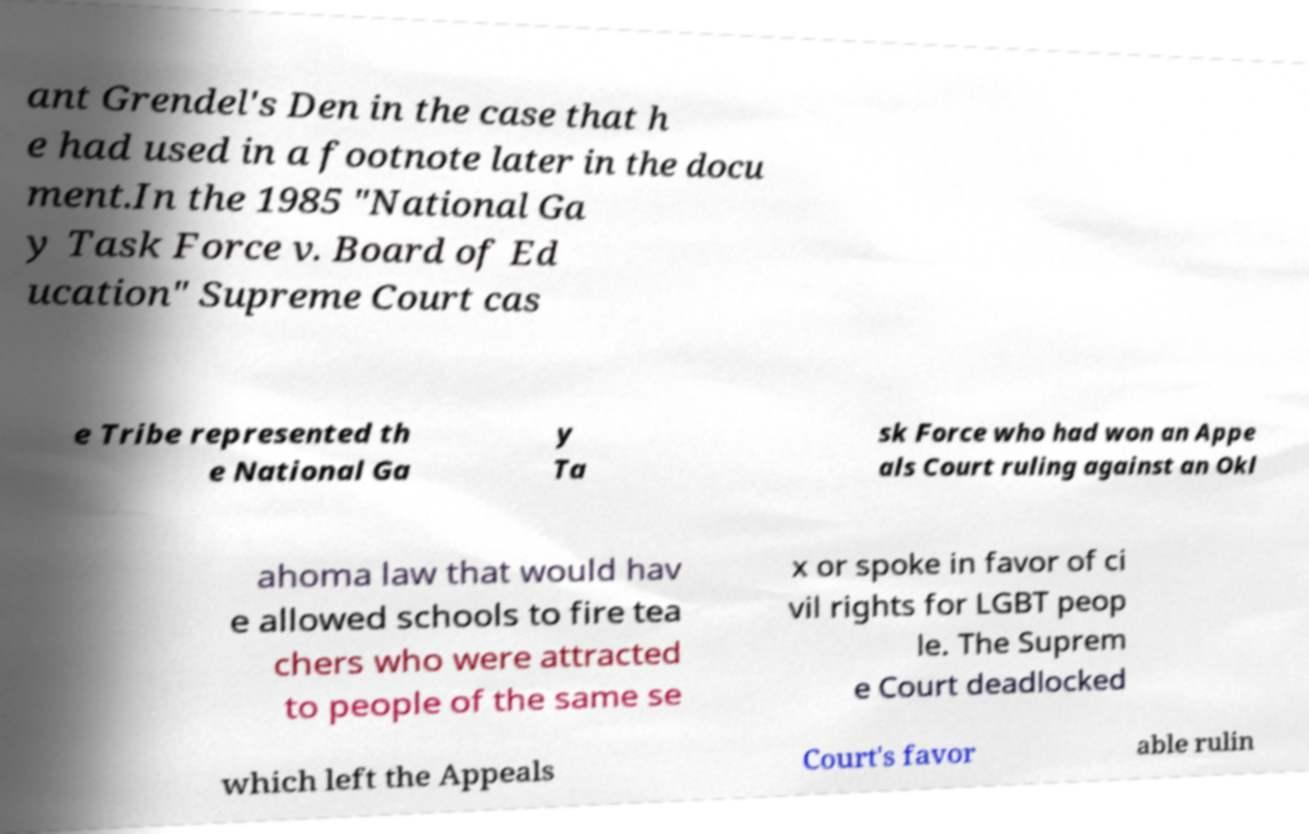Could you assist in decoding the text presented in this image and type it out clearly? ant Grendel's Den in the case that h e had used in a footnote later in the docu ment.In the 1985 "National Ga y Task Force v. Board of Ed ucation" Supreme Court cas e Tribe represented th e National Ga y Ta sk Force who had won an Appe als Court ruling against an Okl ahoma law that would hav e allowed schools to fire tea chers who were attracted to people of the same se x or spoke in favor of ci vil rights for LGBT peop le. The Suprem e Court deadlocked which left the Appeals Court's favor able rulin 